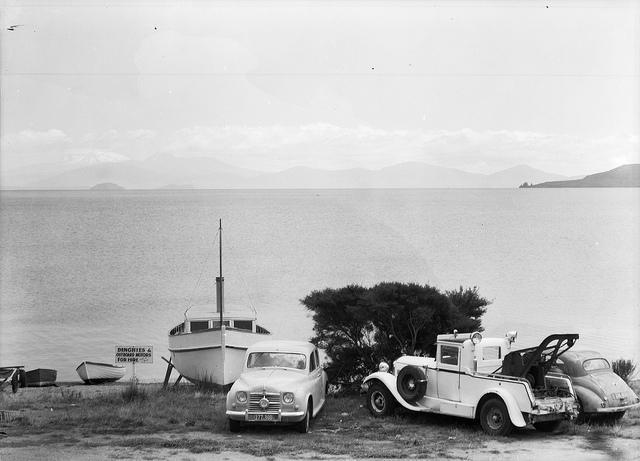How many cars are shown?
Give a very brief answer. 3. How many people is in the truck?
Give a very brief answer. 0. How many cars are visible?
Give a very brief answer. 2. 